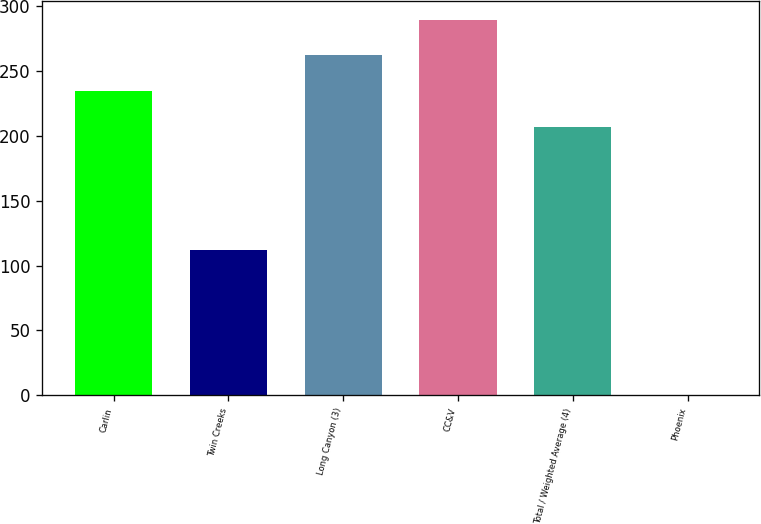Convert chart. <chart><loc_0><loc_0><loc_500><loc_500><bar_chart><fcel>Carlin<fcel>Twin Creeks<fcel>Long Canyon (3)<fcel>CC&V<fcel>Total / Weighted Average (4)<fcel>Phoenix<nl><fcel>234.43<fcel>112<fcel>261.86<fcel>289.29<fcel>207<fcel>0.66<nl></chart> 